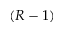Convert formula to latex. <formula><loc_0><loc_0><loc_500><loc_500>( R - 1 )</formula> 